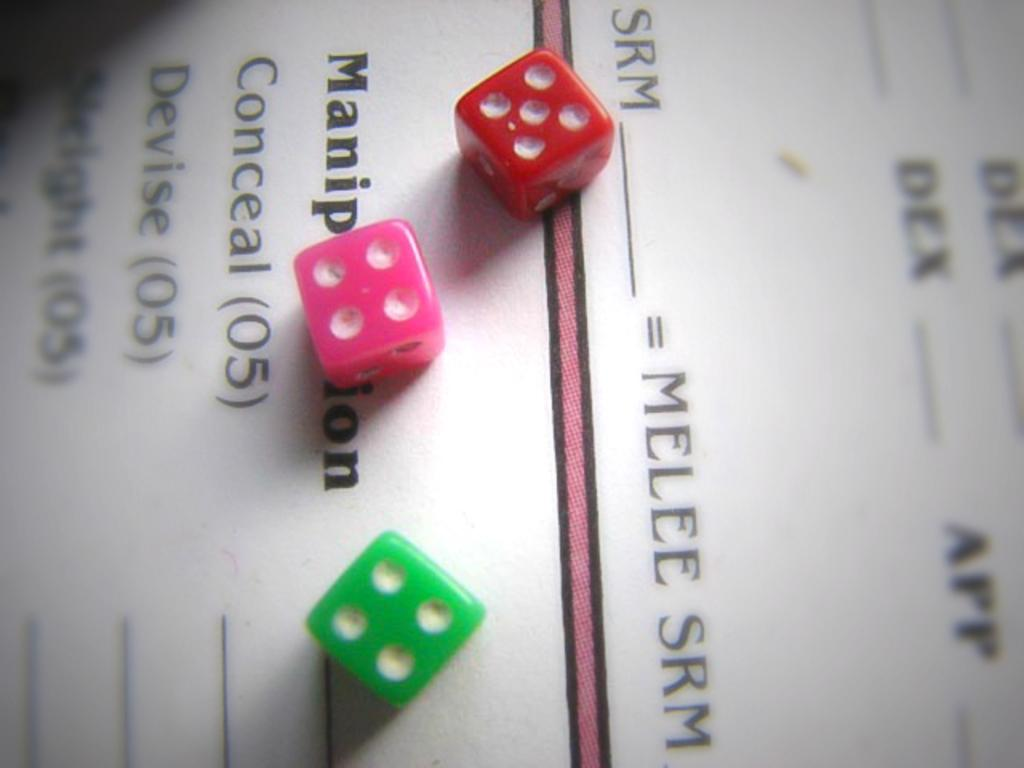What can be seen on the walls in the image? There are posters in the image. What objects are visible on the posters? There is writing on the posters. What type of game or activity might be associated with the objects in the image? The dice in the image suggest a game or activity that involves rolling dice. Can you hear the bears laughing in the image? There are no bears or any indication of laughter in the image. 